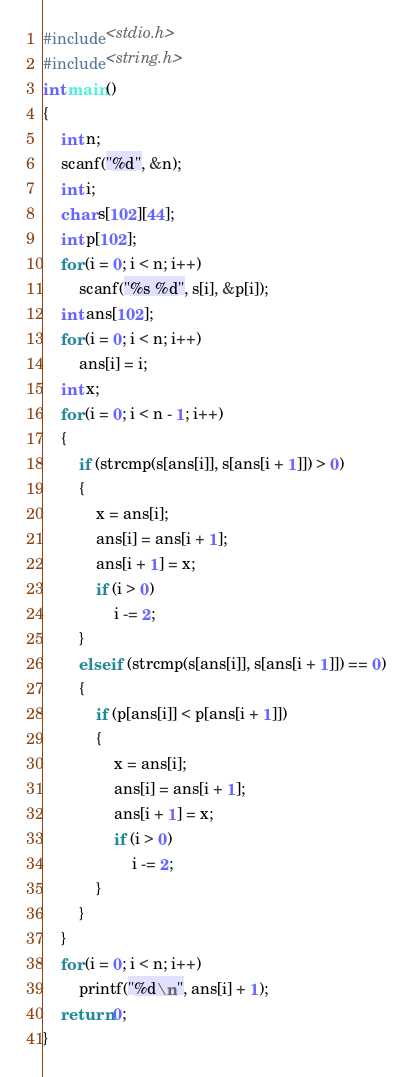Convert code to text. <code><loc_0><loc_0><loc_500><loc_500><_C_>#include<stdio.h>
#include<string.h>
int main()
{
	int n;
	scanf("%d", &n);
	int i;
	char s[102][44];
	int p[102];
	for (i = 0; i < n; i++)
		scanf("%s %d", s[i], &p[i]);
	int ans[102];
	for (i = 0; i < n; i++)
		ans[i] = i;
	int x;
	for (i = 0; i < n - 1; i++)
	{
		if (strcmp(s[ans[i]], s[ans[i + 1]]) > 0)
		{
			x = ans[i];
			ans[i] = ans[i + 1];
			ans[i + 1] = x;
			if (i > 0)
				i -= 2;
		}
		else if (strcmp(s[ans[i]], s[ans[i + 1]]) == 0)
		{
			if (p[ans[i]] < p[ans[i + 1]])
			{
				x = ans[i];
				ans[i] = ans[i + 1];
				ans[i + 1] = x;
				if (i > 0)
					i -= 2;
			}
		}
	}
	for (i = 0; i < n; i++)
		printf("%d\n", ans[i] + 1);
	return 0;
}</code> 